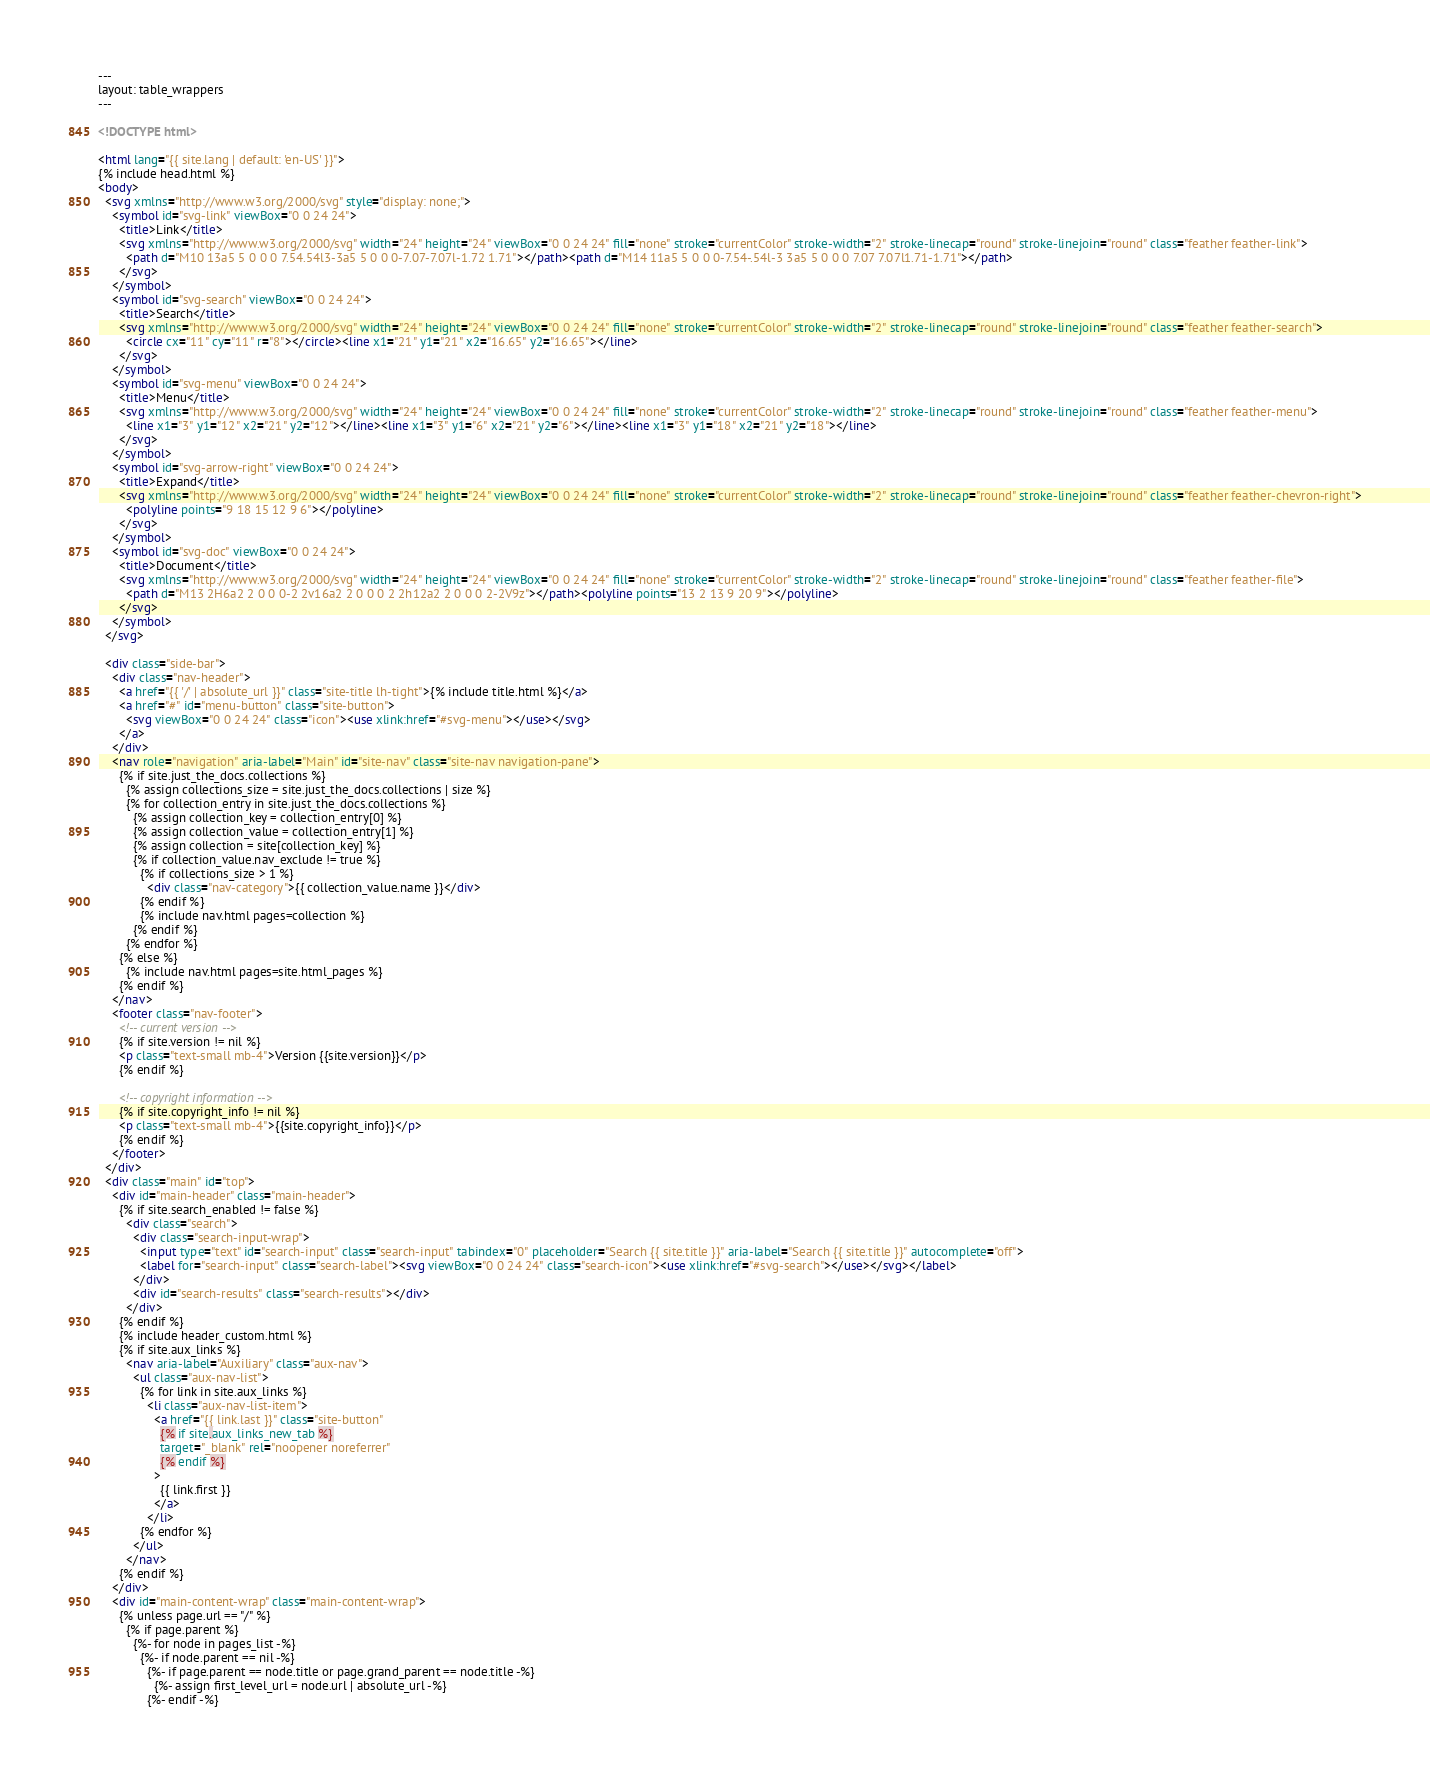<code> <loc_0><loc_0><loc_500><loc_500><_HTML_>---
layout: table_wrappers
---

<!DOCTYPE html>

<html lang="{{ site.lang | default: 'en-US' }}">
{% include head.html %}
<body>
  <svg xmlns="http://www.w3.org/2000/svg" style="display: none;">
    <symbol id="svg-link" viewBox="0 0 24 24">
      <title>Link</title>
      <svg xmlns="http://www.w3.org/2000/svg" width="24" height="24" viewBox="0 0 24 24" fill="none" stroke="currentColor" stroke-width="2" stroke-linecap="round" stroke-linejoin="round" class="feather feather-link">
        <path d="M10 13a5 5 0 0 0 7.54.54l3-3a5 5 0 0 0-7.07-7.07l-1.72 1.71"></path><path d="M14 11a5 5 0 0 0-7.54-.54l-3 3a5 5 0 0 0 7.07 7.07l1.71-1.71"></path>
      </svg>
    </symbol>
    <symbol id="svg-search" viewBox="0 0 24 24">
      <title>Search</title>
      <svg xmlns="http://www.w3.org/2000/svg" width="24" height="24" viewBox="0 0 24 24" fill="none" stroke="currentColor" stroke-width="2" stroke-linecap="round" stroke-linejoin="round" class="feather feather-search">
        <circle cx="11" cy="11" r="8"></circle><line x1="21" y1="21" x2="16.65" y2="16.65"></line>
      </svg>
    </symbol>
    <symbol id="svg-menu" viewBox="0 0 24 24">
      <title>Menu</title>
      <svg xmlns="http://www.w3.org/2000/svg" width="24" height="24" viewBox="0 0 24 24" fill="none" stroke="currentColor" stroke-width="2" stroke-linecap="round" stroke-linejoin="round" class="feather feather-menu">
        <line x1="3" y1="12" x2="21" y2="12"></line><line x1="3" y1="6" x2="21" y2="6"></line><line x1="3" y1="18" x2="21" y2="18"></line>
      </svg>
    </symbol>
    <symbol id="svg-arrow-right" viewBox="0 0 24 24">
      <title>Expand</title>
      <svg xmlns="http://www.w3.org/2000/svg" width="24" height="24" viewBox="0 0 24 24" fill="none" stroke="currentColor" stroke-width="2" stroke-linecap="round" stroke-linejoin="round" class="feather feather-chevron-right">
        <polyline points="9 18 15 12 9 6"></polyline>
      </svg>
    </symbol>
    <symbol id="svg-doc" viewBox="0 0 24 24">
      <title>Document</title>
      <svg xmlns="http://www.w3.org/2000/svg" width="24" height="24" viewBox="0 0 24 24" fill="none" stroke="currentColor" stroke-width="2" stroke-linecap="round" stroke-linejoin="round" class="feather feather-file">
        <path d="M13 2H6a2 2 0 0 0-2 2v16a2 2 0 0 0 2 2h12a2 2 0 0 0 2-2V9z"></path><polyline points="13 2 13 9 20 9"></polyline>
      </svg>
    </symbol>
  </svg>

  <div class="side-bar">
    <div class="nav-header">
      <a href="{{ '/' | absolute_url }}" class="site-title lh-tight">{% include title.html %}</a>
      <a href="#" id="menu-button" class="site-button">
        <svg viewBox="0 0 24 24" class="icon"><use xlink:href="#svg-menu"></use></svg>
      </a>
    </div>
    <nav role="navigation" aria-label="Main" id="site-nav" class="site-nav navigation-pane">
      {% if site.just_the_docs.collections %}
        {% assign collections_size = site.just_the_docs.collections | size %}
        {% for collection_entry in site.just_the_docs.collections %}
          {% assign collection_key = collection_entry[0] %}
          {% assign collection_value = collection_entry[1] %}
          {% assign collection = site[collection_key] %}
          {% if collection_value.nav_exclude != true %}
            {% if collections_size > 1 %}
              <div class="nav-category">{{ collection_value.name }}</div>
            {% endif %}
            {% include nav.html pages=collection %}
          {% endif %}
        {% endfor %}
      {% else %}
        {% include nav.html pages=site.html_pages %}
      {% endif %}
    </nav>
    <footer class="nav-footer">
      <!-- current version -->
      {% if site.version != nil %}
      <p class="text-small mb-4">Version {{site.version}}</p>
      {% endif %}

      <!-- copyright information -->
      {% if site.copyright_info != nil %}
      <p class="text-small mb-4">{{site.copyright_info}}</p>
      {% endif %}
    </footer>
  </div>
  <div class="main" id="top">
    <div id="main-header" class="main-header">
      {% if site.search_enabled != false %}
        <div class="search">
          <div class="search-input-wrap">
            <input type="text" id="search-input" class="search-input" tabindex="0" placeholder="Search {{ site.title }}" aria-label="Search {{ site.title }}" autocomplete="off">
            <label for="search-input" class="search-label"><svg viewBox="0 0 24 24" class="search-icon"><use xlink:href="#svg-search"></use></svg></label>
          </div>
          <div id="search-results" class="search-results"></div>
        </div>
      {% endif %}
      {% include header_custom.html %}
      {% if site.aux_links %}
        <nav aria-label="Auxiliary" class="aux-nav">
          <ul class="aux-nav-list">
            {% for link in site.aux_links %}
              <li class="aux-nav-list-item">
                <a href="{{ link.last }}" class="site-button"
                  {% if site.aux_links_new_tab %}
                  target="_blank" rel="noopener noreferrer"
                  {% endif %}
                >
                  {{ link.first }}
                </a>
              </li>
            {% endfor %}
          </ul>
        </nav>
      {% endif %}
    </div>
    <div id="main-content-wrap" class="main-content-wrap">
      {% unless page.url == "/" %}
        {% if page.parent %}
          {%- for node in pages_list -%}
            {%- if node.parent == nil -%}
              {%- if page.parent == node.title or page.grand_parent == node.title -%}
                {%- assign first_level_url = node.url | absolute_url -%}
              {%- endif -%}</code> 